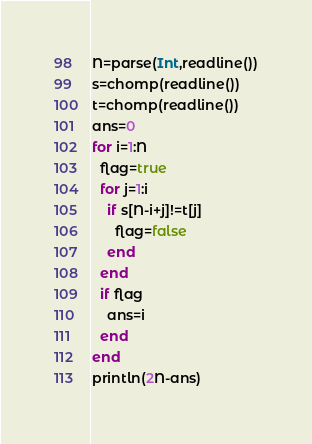Convert code to text. <code><loc_0><loc_0><loc_500><loc_500><_Julia_>N=parse(Int,readline())
s=chomp(readline())
t=chomp(readline())
ans=0
for i=1:N
  flag=true
  for j=1:i
    if s[N-i+j]!=t[j]
      flag=false
    end
  end
  if flag
    ans=i
  end
end
println(2N-ans)</code> 